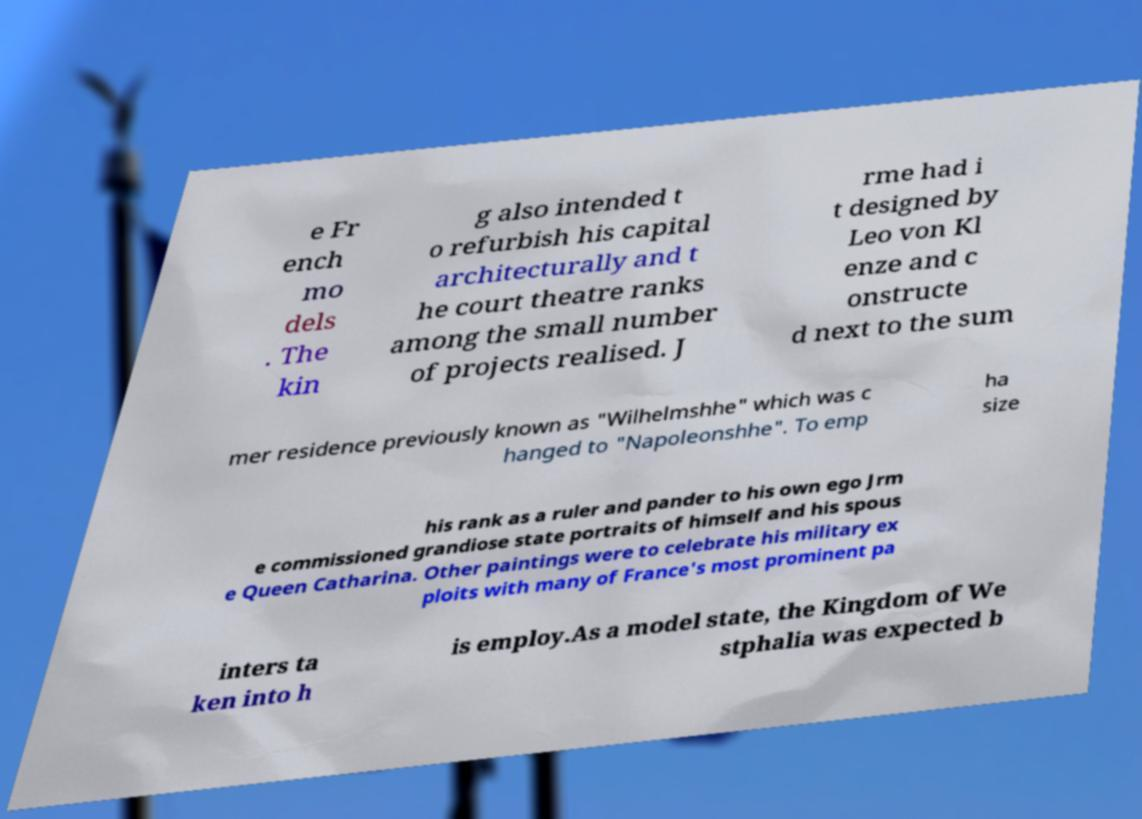What messages or text are displayed in this image? I need them in a readable, typed format. e Fr ench mo dels . The kin g also intended t o refurbish his capital architecturally and t he court theatre ranks among the small number of projects realised. J rme had i t designed by Leo von Kl enze and c onstructe d next to the sum mer residence previously known as "Wilhelmshhe" which was c hanged to "Napoleonshhe". To emp ha size his rank as a ruler and pander to his own ego Jrm e commissioned grandiose state portraits of himself and his spous e Queen Catharina. Other paintings were to celebrate his military ex ploits with many of France's most prominent pa inters ta ken into h is employ.As a model state, the Kingdom of We stphalia was expected b 